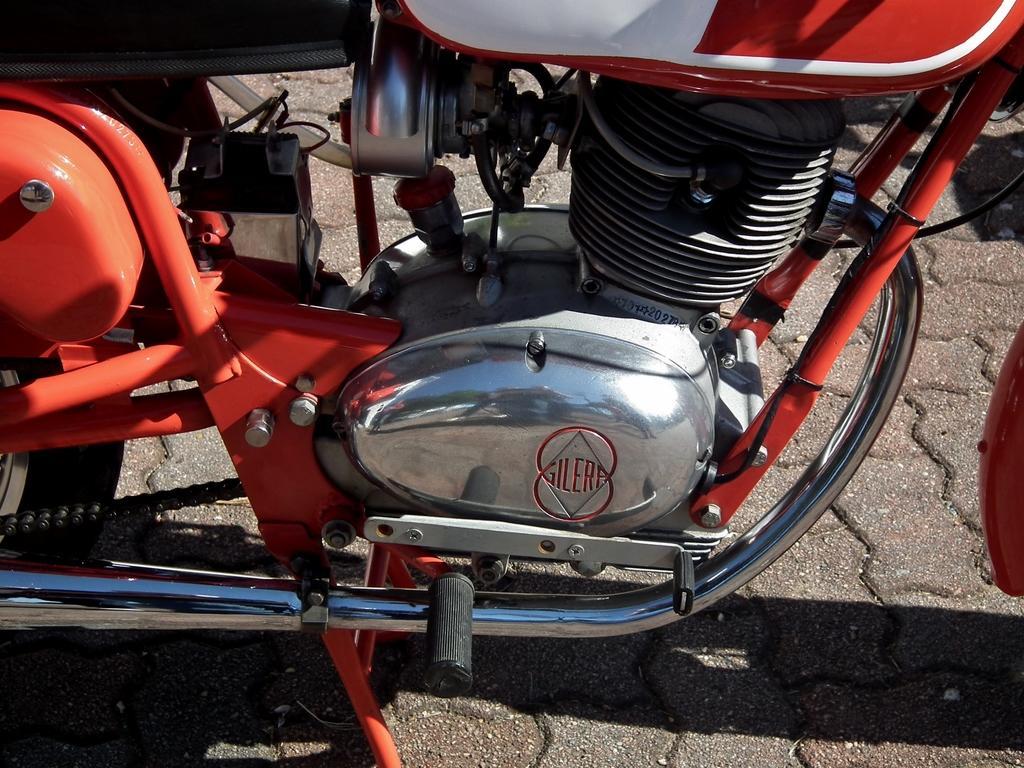How would you summarize this image in a sentence or two? In this picture there is a bike in the center of the image. 